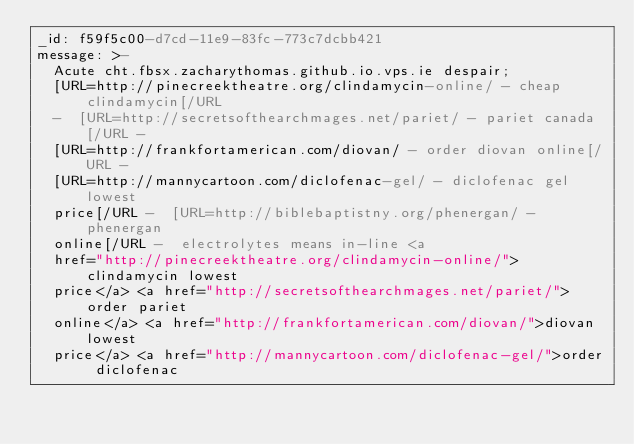<code> <loc_0><loc_0><loc_500><loc_500><_YAML_>_id: f59f5c00-d7cd-11e9-83fc-773c7dcbb421
message: >-
  Acute cht.fbsx.zacharythomas.github.io.vps.ie despair;
  [URL=http://pinecreektheatre.org/clindamycin-online/ - cheap clindamycin[/URL
  -  [URL=http://secretsofthearchmages.net/pariet/ - pariet canada[/URL - 
  [URL=http://frankfortamerican.com/diovan/ - order diovan online[/URL - 
  [URL=http://mannycartoon.com/diclofenac-gel/ - diclofenac gel lowest
  price[/URL -  [URL=http://biblebaptistny.org/phenergan/ - phenergan
  online[/URL -  electrolytes means in-line <a
  href="http://pinecreektheatre.org/clindamycin-online/">clindamycin lowest
  price</a> <a href="http://secretsofthearchmages.net/pariet/">order pariet
  online</a> <a href="http://frankfortamerican.com/diovan/">diovan lowest
  price</a> <a href="http://mannycartoon.com/diclofenac-gel/">order diclofenac</code> 